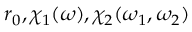<formula> <loc_0><loc_0><loc_500><loc_500>r _ { 0 } , \chi _ { 1 } ( \omega ) , \chi _ { 2 } ( \omega _ { 1 } , \omega _ { 2 } )</formula> 